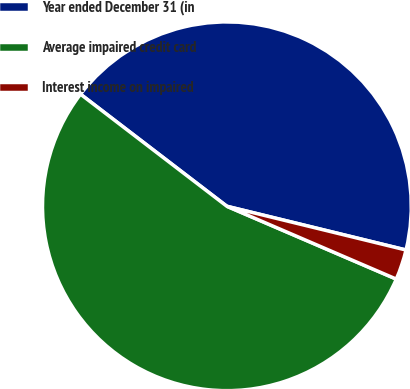<chart> <loc_0><loc_0><loc_500><loc_500><pie_chart><fcel>Year ended December 31 (in<fcel>Average impaired credit card<fcel>Interest income on impaired<nl><fcel>43.41%<fcel>53.94%<fcel>2.65%<nl></chart> 